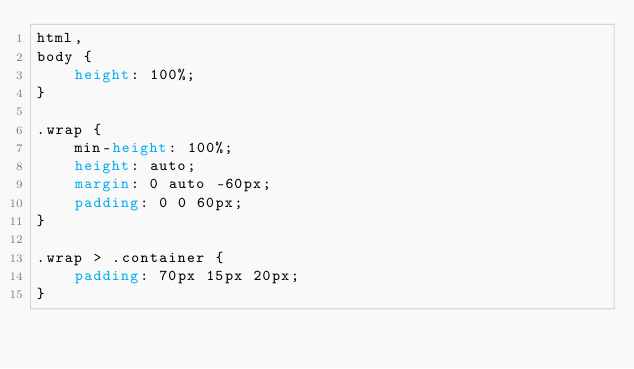Convert code to text. <code><loc_0><loc_0><loc_500><loc_500><_CSS_>html,
body {
    height: 100%;
}

.wrap {
    min-height: 100%;
    height: auto;
    margin: 0 auto -60px;
    padding: 0 0 60px;
}

.wrap > .container {
    padding: 70px 15px 20px;
}
</code> 